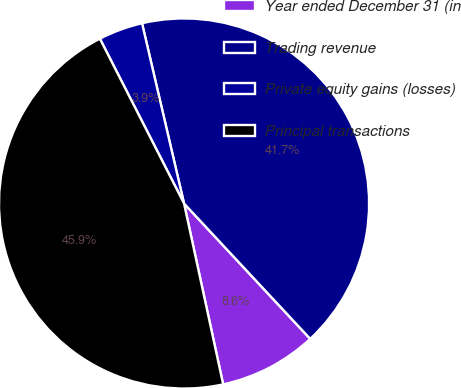<chart> <loc_0><loc_0><loc_500><loc_500><pie_chart><fcel>Year ended December 31 (in<fcel>Trading revenue<fcel>Private equity gains (losses)<fcel>Principal transactions<nl><fcel>8.55%<fcel>41.7%<fcel>3.87%<fcel>45.87%<nl></chart> 